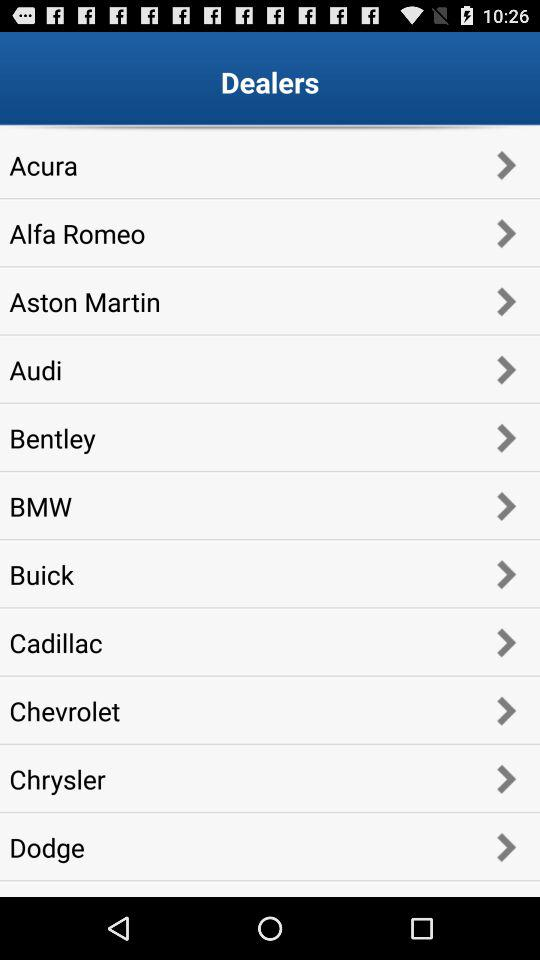Which dealer has the longest name?
Answer the question using a single word or phrase. Aston Martin 